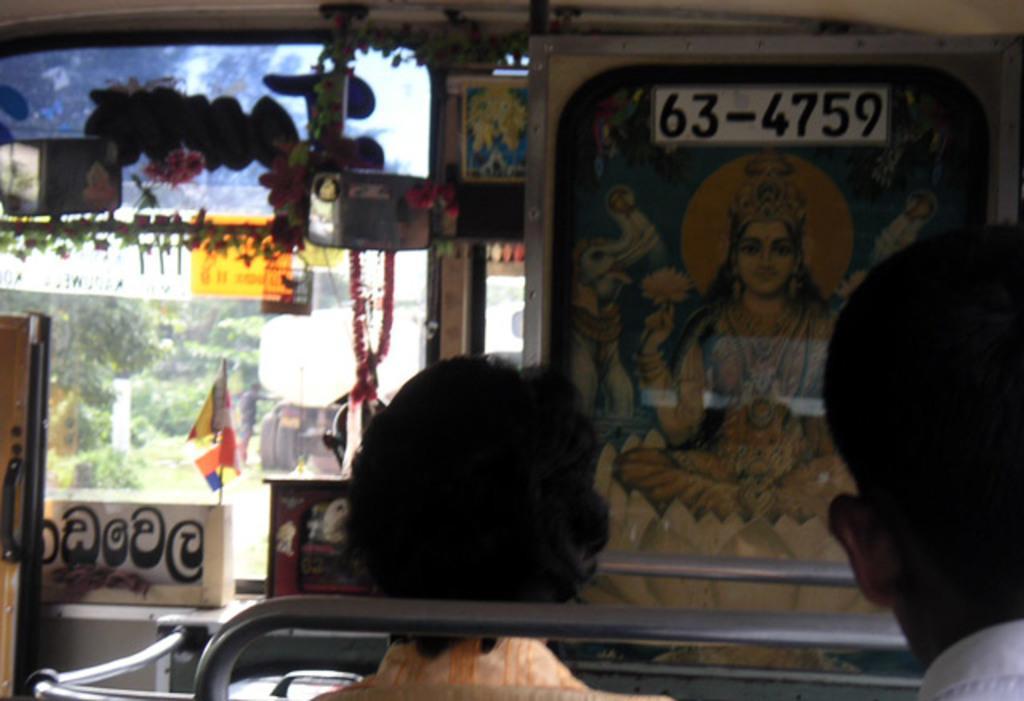Could you give a brief overview of what you see in this image? In this image we can see an inside of a vehicle. There are two persons and metal objects. Behind the persons we can see a poster of a god. There is a mirror, decorative items, a board with text, poster and a glass. Through the glass we can see a person, vehicle, grass, plants and the trees. 